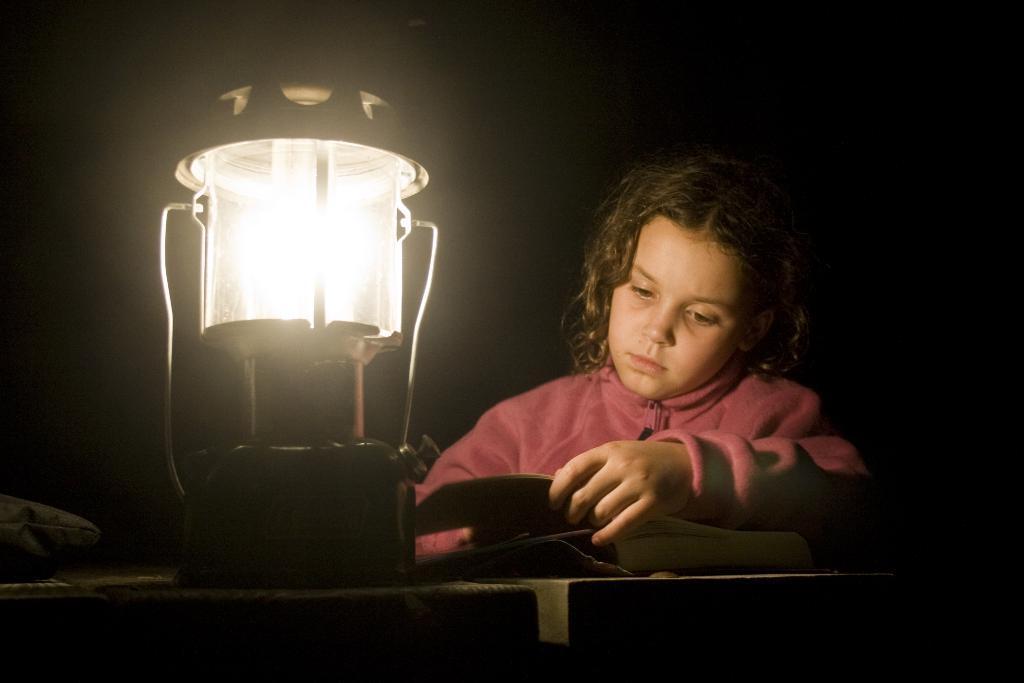Please provide a concise description of this image. There is a lamp and other objects are present on a table as we can see at the bottom of this image. There is a kid on the right side of this image and it is dark in the background. 